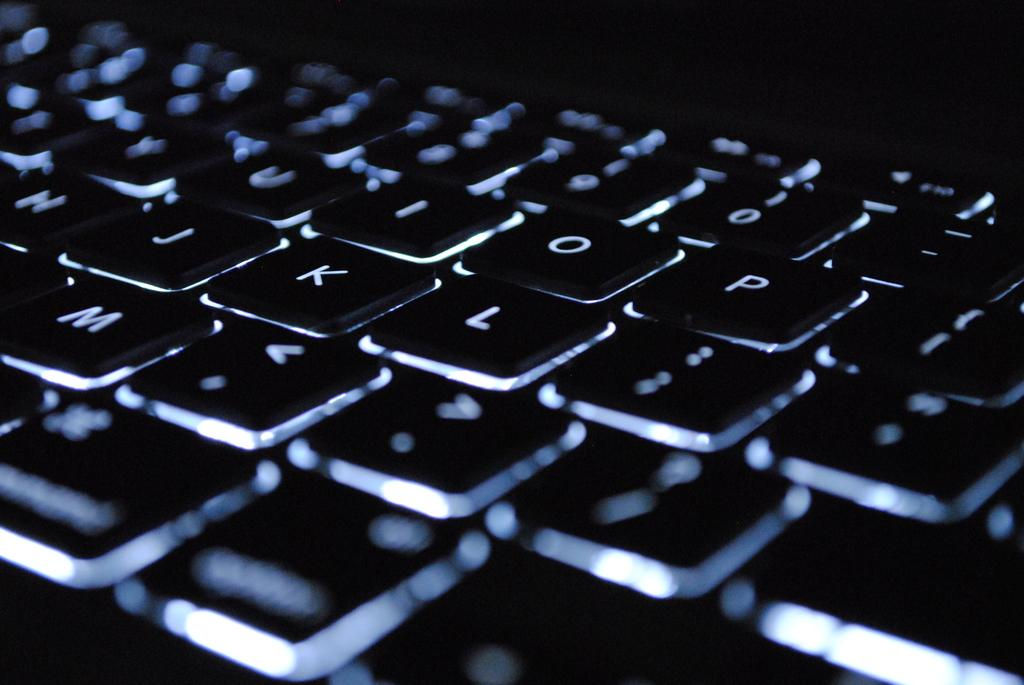<image>
Describe the image concisely. The o, p, k, and l keys, among others are backlit on a keyboard. 